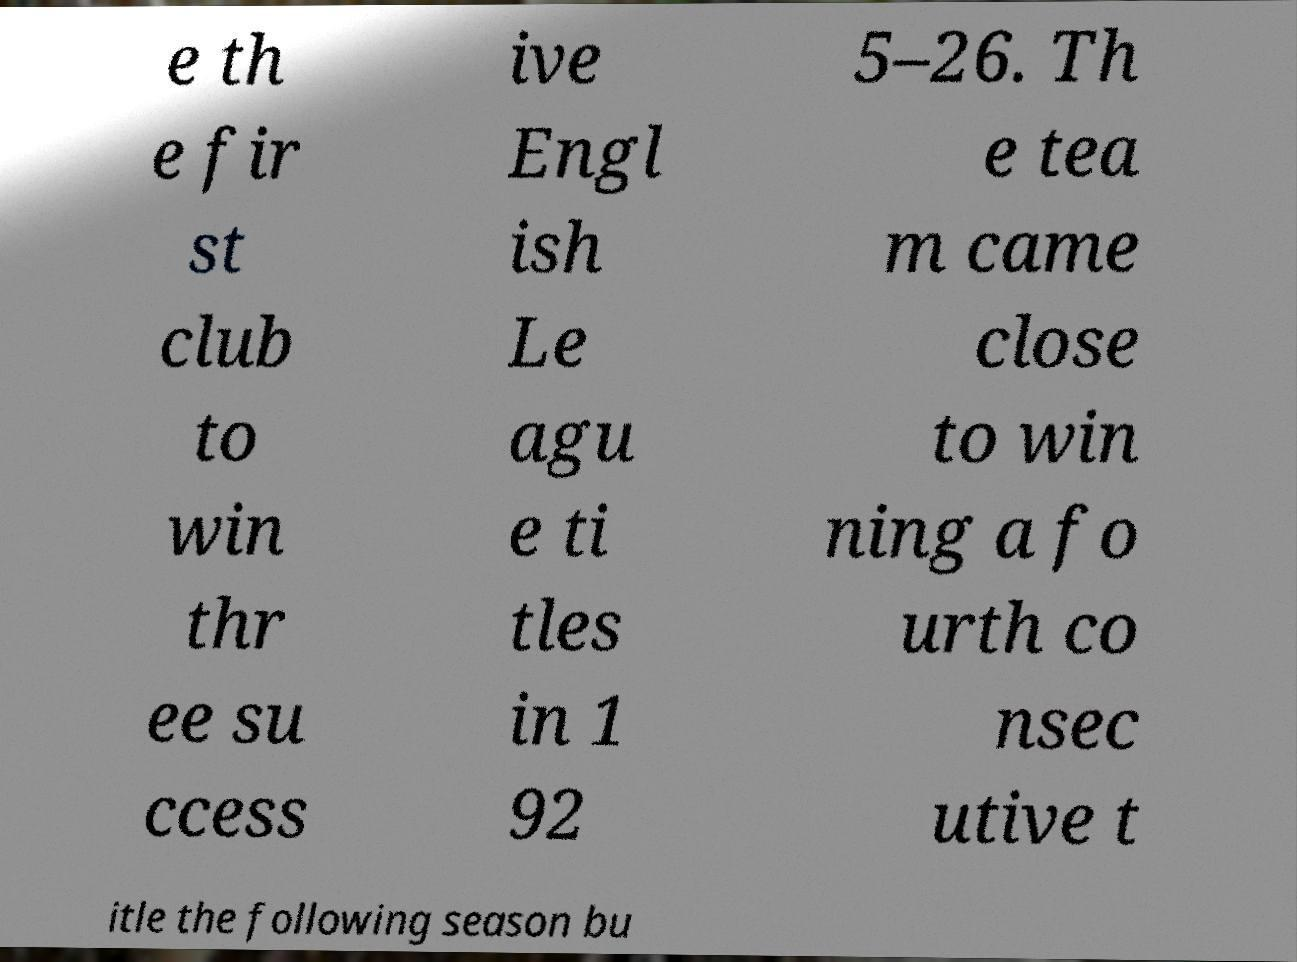Please read and relay the text visible in this image. What does it say? e th e fir st club to win thr ee su ccess ive Engl ish Le agu e ti tles in 1 92 5–26. Th e tea m came close to win ning a fo urth co nsec utive t itle the following season bu 